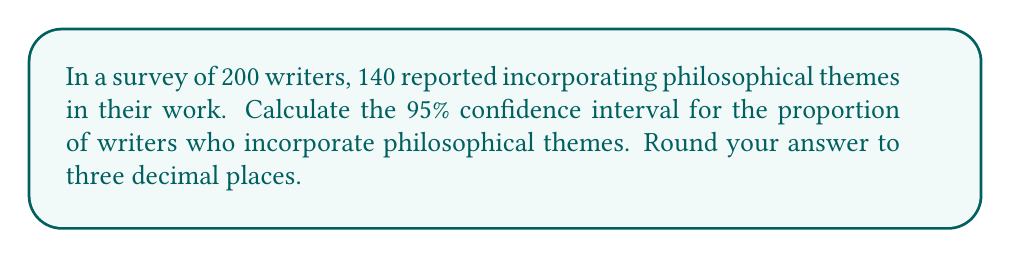Help me with this question. Let's approach this step-by-step:

1) First, we need to calculate the sample proportion:
   $\hat{p} = \frac{\text{number of successes}}{\text{sample size}} = \frac{140}{200} = 0.7$

2) The formula for the confidence interval is:
   $$\hat{p} \pm z_{\alpha/2} \sqrt{\frac{\hat{p}(1-\hat{p})}{n}}$$
   where $z_{\alpha/2}$ is the critical value for the desired confidence level.

3) For a 95% confidence interval, $z_{\alpha/2} = 1.96$

4) Now, let's substitute our values:
   $n = 200$
   $\hat{p} = 0.7$

5) Calculate the standard error:
   $$\sqrt{\frac{\hat{p}(1-\hat{p})}{n}} = \sqrt{\frac{0.7(1-0.7)}{200}} = \sqrt{\frac{0.21}{200}} = 0.0324$$

6) Now we can calculate the margin of error:
   $$1.96 \times 0.0324 = 0.0635$$

7) Therefore, the confidence interval is:
   $$0.7 \pm 0.0635$$

8) This gives us:
   Lower bound: $0.7 - 0.0635 = 0.6365$
   Upper bound: $0.7 + 0.0635 = 0.7635$

9) Rounding to three decimal places:
   $(0.637, 0.764)$
Answer: (0.637, 0.764) 